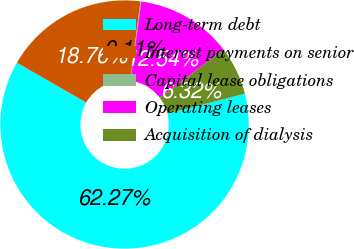Convert chart. <chart><loc_0><loc_0><loc_500><loc_500><pie_chart><fcel>Long-term debt<fcel>Interest payments on senior<fcel>Capital lease obligations<fcel>Operating leases<fcel>Acquisition of dialysis<nl><fcel>62.28%<fcel>18.76%<fcel>0.11%<fcel>12.54%<fcel>6.32%<nl></chart> 